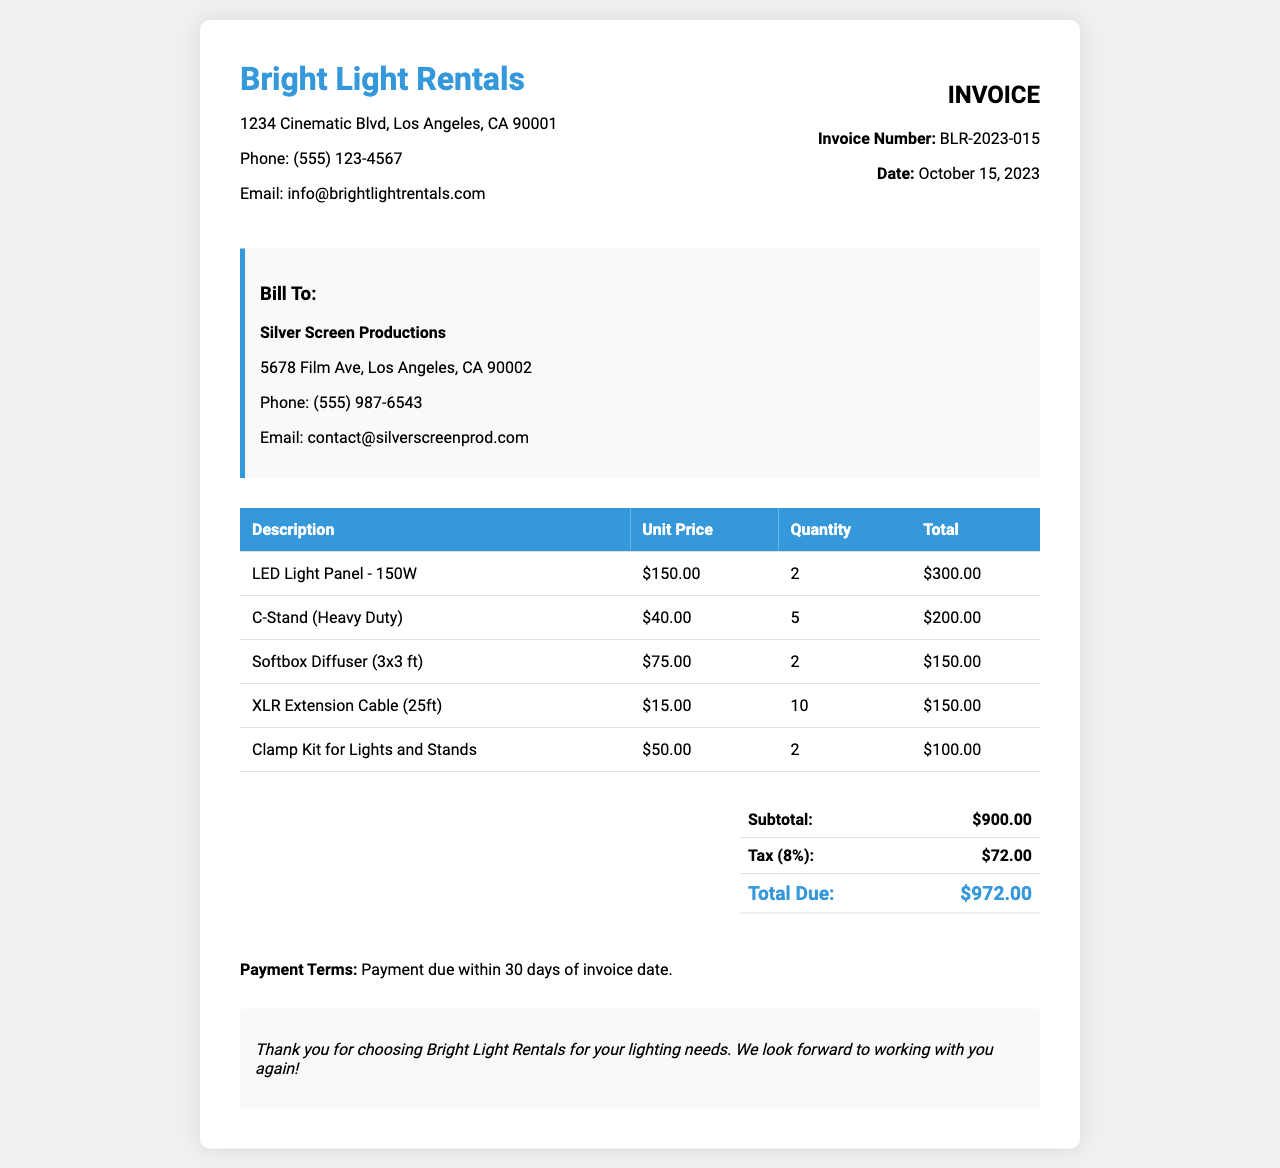What is the invoice number? The invoice number is listed in the document for tracking purposes, which is BLR-2023-015.
Answer: BLR-2023-015 What is the date of the invoice? The date on the invoice indicates when the rental service was billed, which is October 15, 2023.
Answer: October 15, 2023 Who is the client? The client's name appears in the billing section of the invoice, which is Silver Screen Productions.
Answer: Silver Screen Productions What is the total amount due? The total amount due is computed from the subtotal and tax, which totals $972.00.
Answer: $972.00 How many LED Light Panels were rented? The quantity of LED Light Panels rented is specified in the itemized charges, which is 2.
Answer: 2 What is the subtotal before tax? The subtotal before tax is listed in the summary section of the invoice, which is $900.00.
Answer: $900.00 What percentage is the tax applied? The tax percentage applied to the subtotal can be calculated from the invoice summary, which is 8%.
Answer: 8% How many XLR Extension Cables were included in the rental? The quantity of XLR Extension Cables rented is detailed in the invoice, which is 10.
Answer: 10 What is the payment term specified? The payment term details when the payment is due, which states payment due within 30 days.
Answer: 30 days 